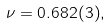<formula> <loc_0><loc_0><loc_500><loc_500>\nu = 0 . 6 8 2 ( 3 ) ,</formula> 